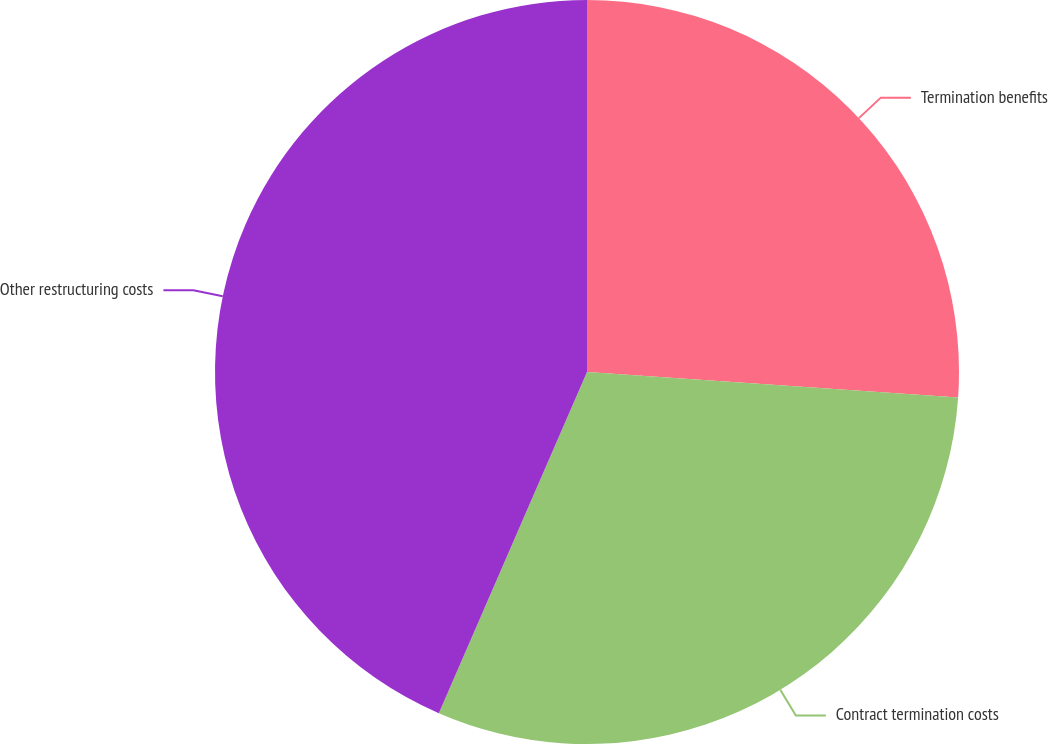Convert chart to OTSL. <chart><loc_0><loc_0><loc_500><loc_500><pie_chart><fcel>Termination benefits<fcel>Contract termination costs<fcel>Other restructuring costs<nl><fcel>26.09%<fcel>30.43%<fcel>43.48%<nl></chart> 